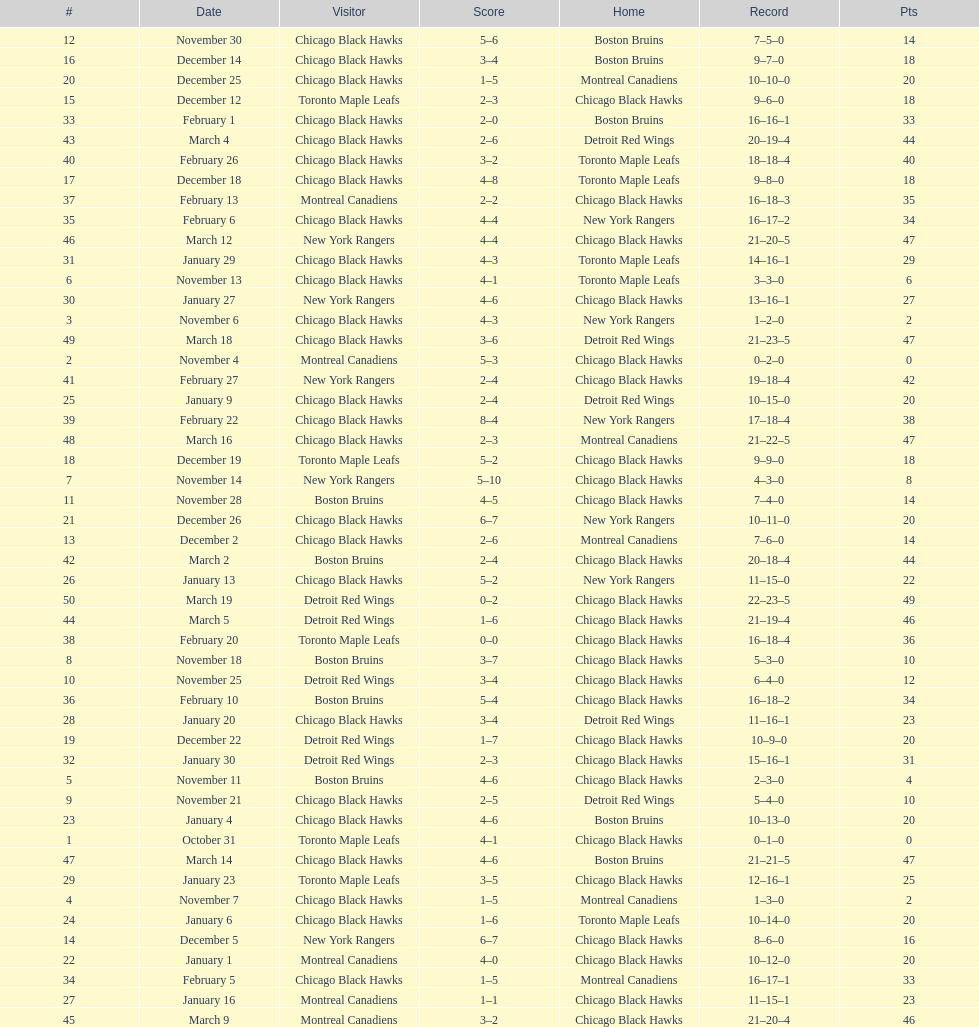Which team was the first one the black hawks lost to? Toronto Maple Leafs. 